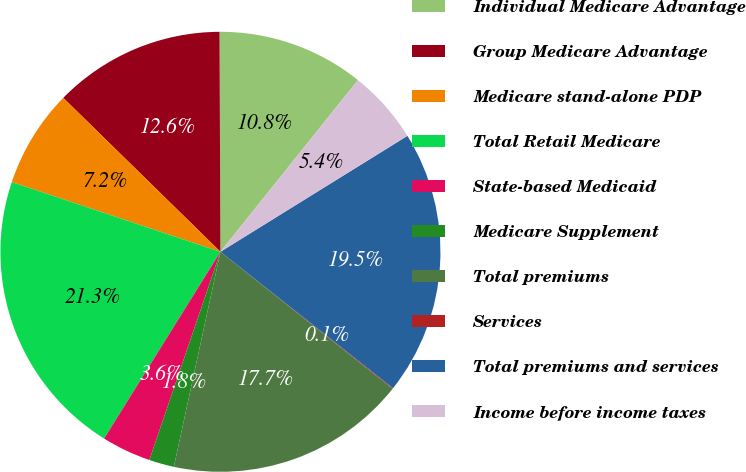Convert chart. <chart><loc_0><loc_0><loc_500><loc_500><pie_chart><fcel>Individual Medicare Advantage<fcel>Group Medicare Advantage<fcel>Medicare stand-alone PDP<fcel>Total Retail Medicare<fcel>State-based Medicaid<fcel>Medicare Supplement<fcel>Total premiums<fcel>Services<fcel>Total premiums and services<fcel>Income before income taxes<nl><fcel>10.81%<fcel>12.6%<fcel>7.2%<fcel>21.27%<fcel>3.63%<fcel>1.84%<fcel>17.7%<fcel>0.05%<fcel>19.48%<fcel>5.42%<nl></chart> 